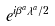Convert formula to latex. <formula><loc_0><loc_0><loc_500><loc_500>e ^ { i \beta ^ { a } \lambda ^ { a } / 2 }</formula> 